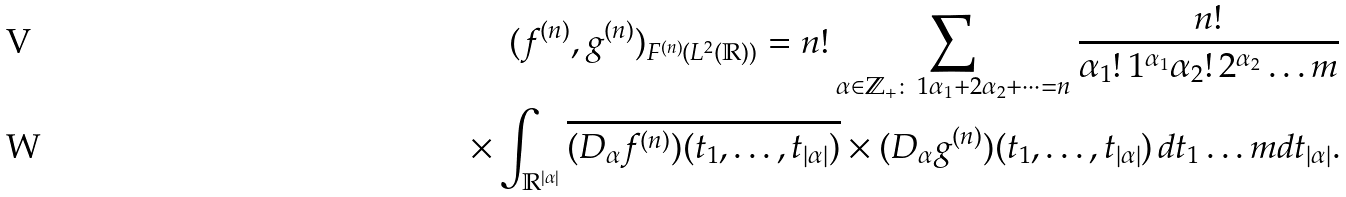<formula> <loc_0><loc_0><loc_500><loc_500>( f ^ { ( n ) } , g ^ { ( n ) } ) _ { F ^ { ( n ) } ( L ^ { 2 } ( { \mathbb { R } } ) ) } = n ! \sum _ { \alpha \in { \mathbb { Z } } _ { + } \colon \, 1 \alpha _ { 1 } + 2 \alpha _ { 2 } + \dots = n } \frac { n ! } { \alpha _ { 1 } ! \, 1 ^ { \alpha _ { 1 } } \alpha _ { 2 } ! \, 2 ^ { \alpha _ { 2 } } \dots m } \\ \times \int _ { { \mathbb { R } } ^ { | \alpha | } } \overline { ( D _ { \alpha } f ^ { ( n ) } ) ( t _ { 1 } , \dots , t _ { | \alpha | } ) } \times ( D _ { \alpha } g ^ { ( n ) } ) ( t _ { 1 } , \dots , t _ { | \alpha | } ) \, d t _ { 1 } \dots m d t _ { | \alpha | } .</formula> 